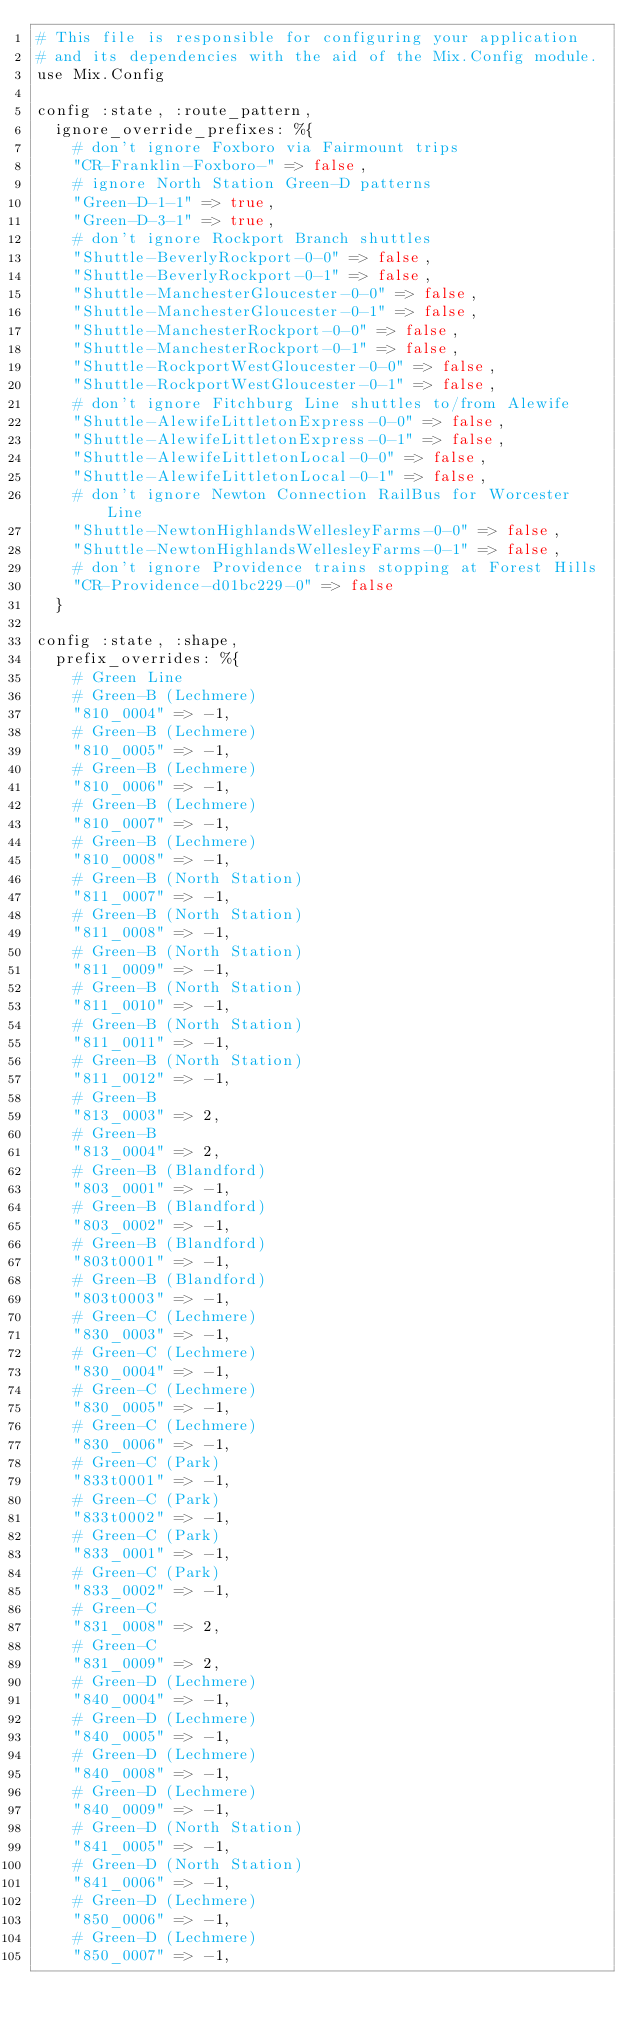Convert code to text. <code><loc_0><loc_0><loc_500><loc_500><_Elixir_># This file is responsible for configuring your application
# and its dependencies with the aid of the Mix.Config module.
use Mix.Config

config :state, :route_pattern,
  ignore_override_prefixes: %{
    # don't ignore Foxboro via Fairmount trips
    "CR-Franklin-Foxboro-" => false,
    # ignore North Station Green-D patterns
    "Green-D-1-1" => true,
    "Green-D-3-1" => true,
    # don't ignore Rockport Branch shuttles
    "Shuttle-BeverlyRockport-0-0" => false,
    "Shuttle-BeverlyRockport-0-1" => false,
    "Shuttle-ManchesterGloucester-0-0" => false,
    "Shuttle-ManchesterGloucester-0-1" => false,
    "Shuttle-ManchesterRockport-0-0" => false,
    "Shuttle-ManchesterRockport-0-1" => false,
    "Shuttle-RockportWestGloucester-0-0" => false,
    "Shuttle-RockportWestGloucester-0-1" => false,
    # don't ignore Fitchburg Line shuttles to/from Alewife
    "Shuttle-AlewifeLittletonExpress-0-0" => false,
    "Shuttle-AlewifeLittletonExpress-0-1" => false,
    "Shuttle-AlewifeLittletonLocal-0-0" => false,
    "Shuttle-AlewifeLittletonLocal-0-1" => false,
    # don't ignore Newton Connection RailBus for Worcester Line
    "Shuttle-NewtonHighlandsWellesleyFarms-0-0" => false,
    "Shuttle-NewtonHighlandsWellesleyFarms-0-1" => false,
    # don't ignore Providence trains stopping at Forest Hills
    "CR-Providence-d01bc229-0" => false
  }

config :state, :shape,
  prefix_overrides: %{
    # Green Line
    # Green-B (Lechmere)
    "810_0004" => -1,
    # Green-B (Lechmere)
    "810_0005" => -1,
    # Green-B (Lechmere)
    "810_0006" => -1,
    # Green-B (Lechmere)
    "810_0007" => -1,
    # Green-B (Lechmere)
    "810_0008" => -1,
    # Green-B (North Station)
    "811_0007" => -1,
    # Green-B (North Station)
    "811_0008" => -1,
    # Green-B (North Station)
    "811_0009" => -1,
    # Green-B (North Station)
    "811_0010" => -1,
    # Green-B (North Station)
    "811_0011" => -1,
    # Green-B (North Station)
    "811_0012" => -1,
    # Green-B
    "813_0003" => 2,
    # Green-B
    "813_0004" => 2,
    # Green-B (Blandford)
    "803_0001" => -1,
    # Green-B (Blandford)
    "803_0002" => -1,
    # Green-B (Blandford)
    "803t0001" => -1,
    # Green-B (Blandford)
    "803t0003" => -1,
    # Green-C (Lechmere)
    "830_0003" => -1,
    # Green-C (Lechmere)
    "830_0004" => -1,
    # Green-C (Lechmere)
    "830_0005" => -1,
    # Green-C (Lechmere)
    "830_0006" => -1,
    # Green-C (Park)
    "833t0001" => -1,
    # Green-C (Park)
    "833t0002" => -1,
    # Green-C (Park)
    "833_0001" => -1,
    # Green-C (Park)
    "833_0002" => -1,
    # Green-C
    "831_0008" => 2,
    # Green-C
    "831_0009" => 2,
    # Green-D (Lechmere)
    "840_0004" => -1,
    # Green-D (Lechmere)
    "840_0005" => -1,
    # Green-D (Lechmere)
    "840_0008" => -1,
    # Green-D (Lechmere)
    "840_0009" => -1,
    # Green-D (North Station)
    "841_0005" => -1,
    # Green-D (North Station)
    "841_0006" => -1,
    # Green-D (Lechmere)
    "850_0006" => -1,
    # Green-D (Lechmere)
    "850_0007" => -1,</code> 